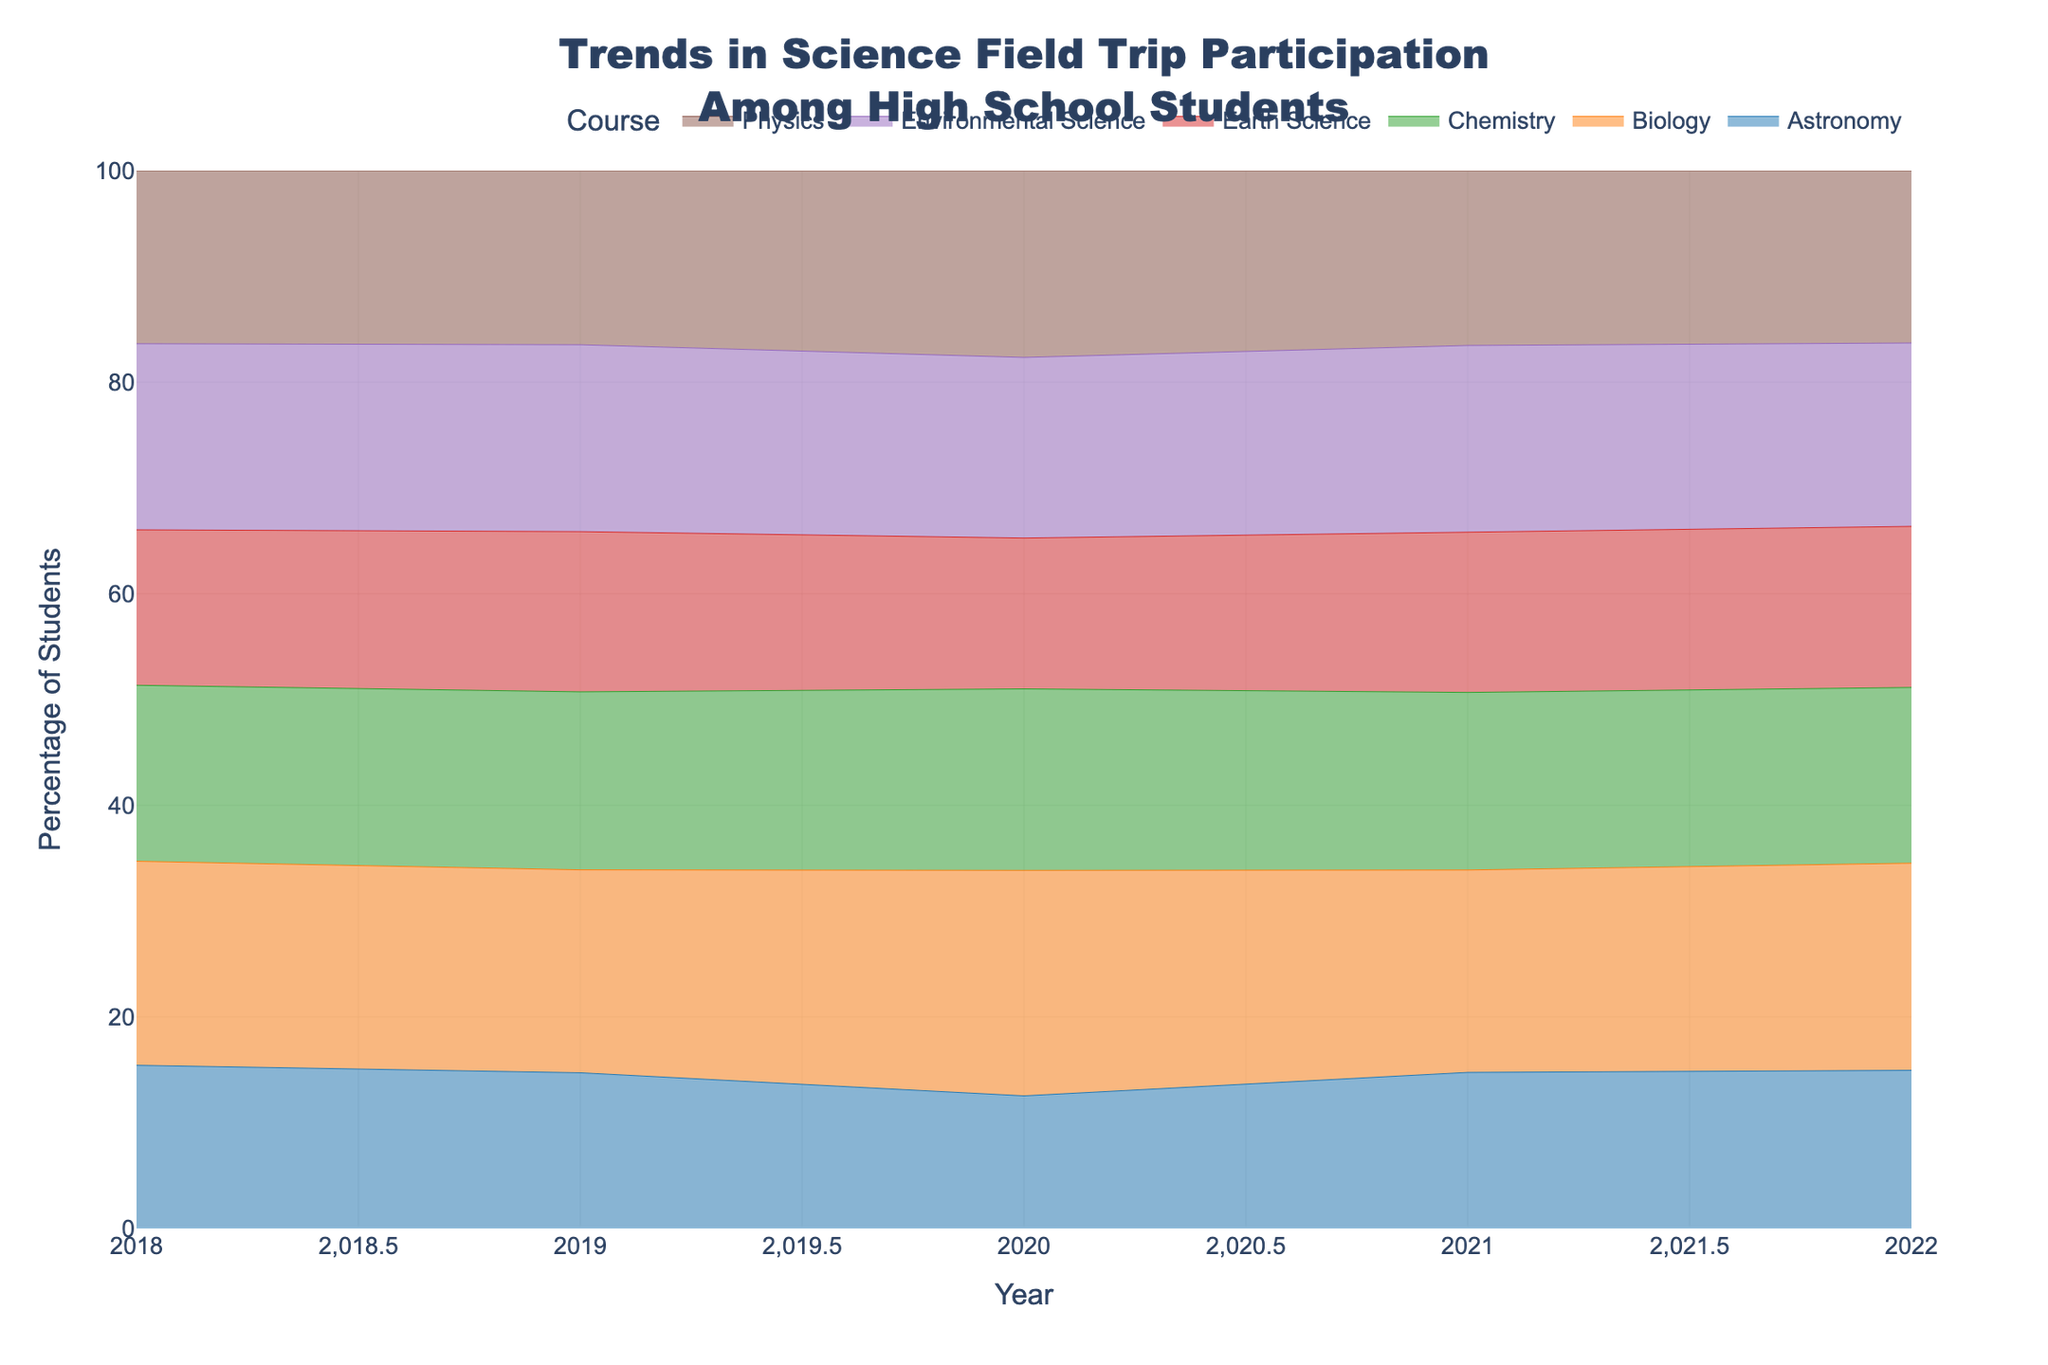What is the title of the figure? The title is usually located at the top of a figure and describes what the graph represents. Here, it reads "Trends in Science Field Trip Participation Among High School Students."
Answer: Trends in Science Field Trip Participation Among High School Students What does the y-axis represent? The y-axis typically represents the measure used in the figure. In this case, it is labeled as "Percentage of Students," which indicates the percentage of students who participate in field trips.
Answer: Percentage of Students Which subject had the highest field trip participation percentage in 2022? To find this, look at the height of the streams in the year 2022 and identify which course has the highest point.
Answer: Environmental Science Did the percentage of students participating in Physics field trips increase or decrease from 2020 to 2021? Compare the height of the Physics stream (usually in a unique color) from 2020 to 2021. Identify if it moves up or down.
Answer: Increased In which year did Chemistry have the lowest field trip participation percentage? Scan through the Chemistry stream across all years and find the year where the percentage (height of the stream) is the lowest.
Answer: 2020 What trend do we observe in Earth Science field trip participation from 2018 to 2022? Observe the Earth Science stream over the years from 2018 to 2022. Look if the percentage is increasing, decreasing, or fluctuating over these years.
Answer: Increasing How many different subjects are shown in the figure? Count the different color-coded streams representing different subjects. Each unique color corresponds to a different subject.
Answer: 6 Which subject shows the most increase in field trip participation percentage between 2019 and 2020? For each subject, compare the heights of the streams in 2019 and 2020. Identify the subject with the most noticeable increase.
Answer: Environmental Science By how much did the Biology field trip participation percentage change from 2018 to 2019? Calculate the difference in the height of the Biology stream between the years 2018 and 2019. This tells how much it increased or decreased.
Answer: Increased by 2% Which subject has the most stable participation trend across the years shown? Look for the stream that fluctuates the least in height across the years. This indicates stability in participation percentage.
Answer: Astronomy 